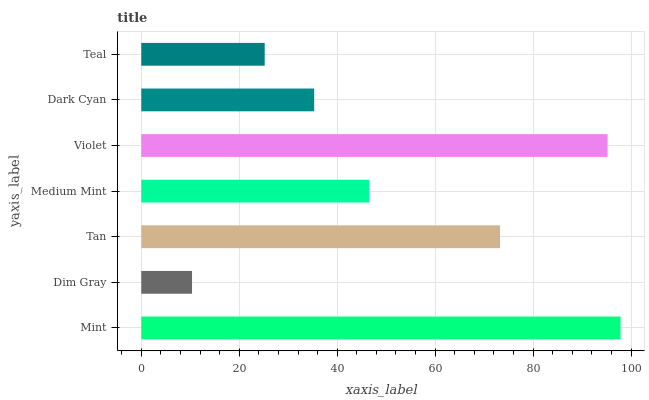Is Dim Gray the minimum?
Answer yes or no. Yes. Is Mint the maximum?
Answer yes or no. Yes. Is Tan the minimum?
Answer yes or no. No. Is Tan the maximum?
Answer yes or no. No. Is Tan greater than Dim Gray?
Answer yes or no. Yes. Is Dim Gray less than Tan?
Answer yes or no. Yes. Is Dim Gray greater than Tan?
Answer yes or no. No. Is Tan less than Dim Gray?
Answer yes or no. No. Is Medium Mint the high median?
Answer yes or no. Yes. Is Medium Mint the low median?
Answer yes or no. Yes. Is Tan the high median?
Answer yes or no. No. Is Dim Gray the low median?
Answer yes or no. No. 